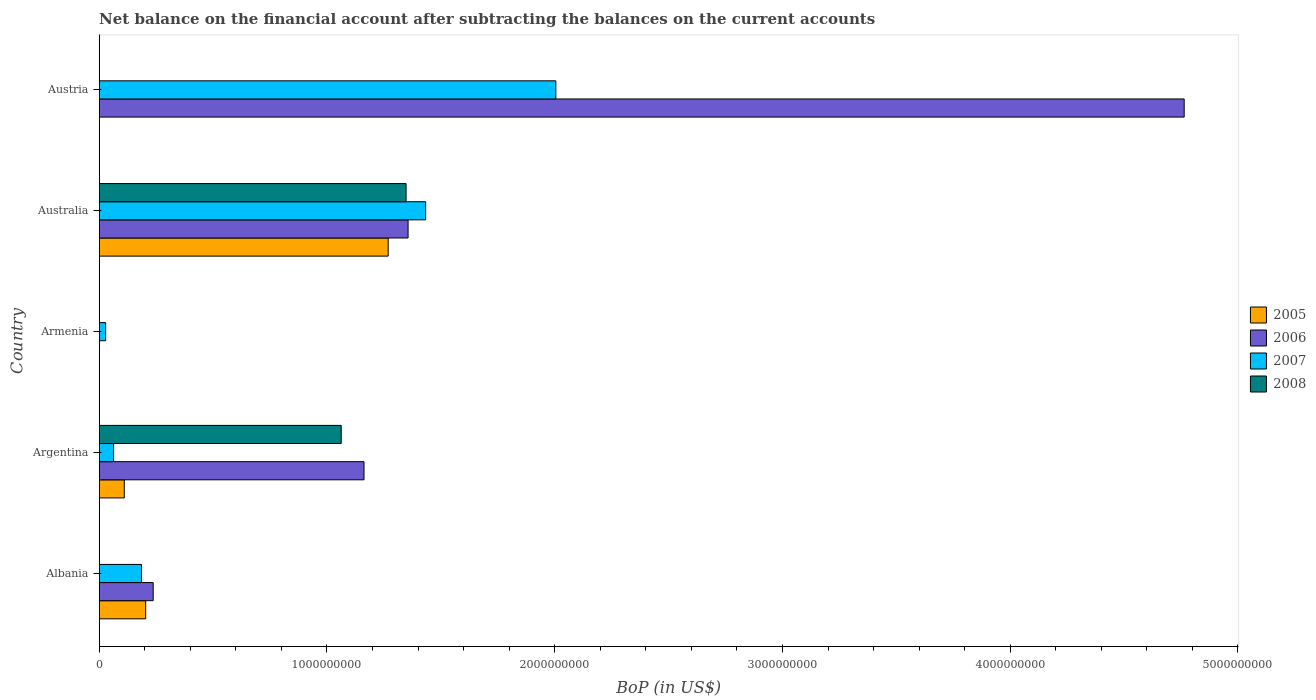Are the number of bars per tick equal to the number of legend labels?
Your response must be concise. No. How many bars are there on the 1st tick from the top?
Your answer should be compact. 2. What is the label of the 5th group of bars from the top?
Your answer should be compact. Albania. What is the Balance of Payments in 2007 in Austria?
Provide a succinct answer. 2.00e+09. Across all countries, what is the maximum Balance of Payments in 2008?
Offer a terse response. 1.35e+09. Across all countries, what is the minimum Balance of Payments in 2005?
Your answer should be very brief. 0. In which country was the Balance of Payments in 2005 maximum?
Your response must be concise. Australia. What is the total Balance of Payments in 2008 in the graph?
Provide a succinct answer. 2.41e+09. What is the difference between the Balance of Payments in 2007 in Albania and that in Argentina?
Ensure brevity in your answer.  1.22e+08. What is the difference between the Balance of Payments in 2006 in Austria and the Balance of Payments in 2008 in Armenia?
Your answer should be compact. 4.76e+09. What is the average Balance of Payments in 2008 per country?
Provide a short and direct response. 4.82e+08. What is the difference between the Balance of Payments in 2005 and Balance of Payments in 2007 in Australia?
Make the answer very short. -1.65e+08. In how many countries, is the Balance of Payments in 2005 greater than 2400000000 US$?
Your response must be concise. 0. What is the ratio of the Balance of Payments in 2006 in Australia to that in Austria?
Offer a terse response. 0.28. What is the difference between the highest and the second highest Balance of Payments in 2005?
Your answer should be compact. 1.06e+09. What is the difference between the highest and the lowest Balance of Payments in 2007?
Your response must be concise. 1.98e+09. Are all the bars in the graph horizontal?
Give a very brief answer. Yes. How many countries are there in the graph?
Keep it short and to the point. 5. Does the graph contain any zero values?
Offer a very short reply. Yes. Does the graph contain grids?
Ensure brevity in your answer.  No. Where does the legend appear in the graph?
Make the answer very short. Center right. How many legend labels are there?
Offer a very short reply. 4. What is the title of the graph?
Ensure brevity in your answer.  Net balance on the financial account after subtracting the balances on the current accounts. What is the label or title of the X-axis?
Your response must be concise. BoP (in US$). What is the BoP (in US$) of 2005 in Albania?
Ensure brevity in your answer.  2.04e+08. What is the BoP (in US$) of 2006 in Albania?
Keep it short and to the point. 2.37e+08. What is the BoP (in US$) in 2007 in Albania?
Offer a very short reply. 1.86e+08. What is the BoP (in US$) of 2005 in Argentina?
Make the answer very short. 1.10e+08. What is the BoP (in US$) of 2006 in Argentina?
Offer a very short reply. 1.16e+09. What is the BoP (in US$) of 2007 in Argentina?
Provide a succinct answer. 6.32e+07. What is the BoP (in US$) in 2008 in Argentina?
Your answer should be compact. 1.06e+09. What is the BoP (in US$) in 2005 in Armenia?
Provide a succinct answer. 0. What is the BoP (in US$) in 2007 in Armenia?
Your answer should be very brief. 2.83e+07. What is the BoP (in US$) in 2005 in Australia?
Give a very brief answer. 1.27e+09. What is the BoP (in US$) in 2006 in Australia?
Make the answer very short. 1.36e+09. What is the BoP (in US$) in 2007 in Australia?
Provide a succinct answer. 1.43e+09. What is the BoP (in US$) in 2008 in Australia?
Offer a very short reply. 1.35e+09. What is the BoP (in US$) in 2005 in Austria?
Offer a terse response. 0. What is the BoP (in US$) in 2006 in Austria?
Your response must be concise. 4.76e+09. What is the BoP (in US$) of 2007 in Austria?
Keep it short and to the point. 2.00e+09. What is the BoP (in US$) in 2008 in Austria?
Your response must be concise. 0. Across all countries, what is the maximum BoP (in US$) of 2005?
Your answer should be compact. 1.27e+09. Across all countries, what is the maximum BoP (in US$) of 2006?
Offer a very short reply. 4.76e+09. Across all countries, what is the maximum BoP (in US$) in 2007?
Ensure brevity in your answer.  2.00e+09. Across all countries, what is the maximum BoP (in US$) in 2008?
Provide a succinct answer. 1.35e+09. Across all countries, what is the minimum BoP (in US$) in 2005?
Provide a short and direct response. 0. Across all countries, what is the minimum BoP (in US$) of 2006?
Ensure brevity in your answer.  0. Across all countries, what is the minimum BoP (in US$) of 2007?
Your response must be concise. 2.83e+07. What is the total BoP (in US$) of 2005 in the graph?
Your response must be concise. 1.58e+09. What is the total BoP (in US$) in 2006 in the graph?
Offer a very short reply. 7.52e+09. What is the total BoP (in US$) of 2007 in the graph?
Your response must be concise. 3.72e+09. What is the total BoP (in US$) in 2008 in the graph?
Give a very brief answer. 2.41e+09. What is the difference between the BoP (in US$) in 2005 in Albania and that in Argentina?
Your response must be concise. 9.40e+07. What is the difference between the BoP (in US$) in 2006 in Albania and that in Argentina?
Ensure brevity in your answer.  -9.26e+08. What is the difference between the BoP (in US$) of 2007 in Albania and that in Argentina?
Make the answer very short. 1.22e+08. What is the difference between the BoP (in US$) of 2007 in Albania and that in Armenia?
Give a very brief answer. 1.57e+08. What is the difference between the BoP (in US$) of 2005 in Albania and that in Australia?
Keep it short and to the point. -1.06e+09. What is the difference between the BoP (in US$) of 2006 in Albania and that in Australia?
Your response must be concise. -1.12e+09. What is the difference between the BoP (in US$) in 2007 in Albania and that in Australia?
Make the answer very short. -1.25e+09. What is the difference between the BoP (in US$) in 2006 in Albania and that in Austria?
Keep it short and to the point. -4.53e+09. What is the difference between the BoP (in US$) in 2007 in Albania and that in Austria?
Your answer should be compact. -1.82e+09. What is the difference between the BoP (in US$) in 2007 in Argentina and that in Armenia?
Your response must be concise. 3.49e+07. What is the difference between the BoP (in US$) of 2005 in Argentina and that in Australia?
Provide a succinct answer. -1.16e+09. What is the difference between the BoP (in US$) of 2006 in Argentina and that in Australia?
Offer a terse response. -1.94e+08. What is the difference between the BoP (in US$) in 2007 in Argentina and that in Australia?
Give a very brief answer. -1.37e+09. What is the difference between the BoP (in US$) in 2008 in Argentina and that in Australia?
Provide a short and direct response. -2.85e+08. What is the difference between the BoP (in US$) in 2006 in Argentina and that in Austria?
Your response must be concise. -3.60e+09. What is the difference between the BoP (in US$) of 2007 in Argentina and that in Austria?
Your answer should be very brief. -1.94e+09. What is the difference between the BoP (in US$) of 2007 in Armenia and that in Australia?
Your answer should be very brief. -1.41e+09. What is the difference between the BoP (in US$) of 2007 in Armenia and that in Austria?
Your response must be concise. -1.98e+09. What is the difference between the BoP (in US$) of 2006 in Australia and that in Austria?
Your answer should be compact. -3.41e+09. What is the difference between the BoP (in US$) in 2007 in Australia and that in Austria?
Offer a terse response. -5.72e+08. What is the difference between the BoP (in US$) of 2005 in Albania and the BoP (in US$) of 2006 in Argentina?
Give a very brief answer. -9.59e+08. What is the difference between the BoP (in US$) of 2005 in Albania and the BoP (in US$) of 2007 in Argentina?
Your answer should be compact. 1.41e+08. What is the difference between the BoP (in US$) in 2005 in Albania and the BoP (in US$) in 2008 in Argentina?
Offer a very short reply. -8.59e+08. What is the difference between the BoP (in US$) in 2006 in Albania and the BoP (in US$) in 2007 in Argentina?
Offer a very short reply. 1.74e+08. What is the difference between the BoP (in US$) in 2006 in Albania and the BoP (in US$) in 2008 in Argentina?
Give a very brief answer. -8.26e+08. What is the difference between the BoP (in US$) in 2007 in Albania and the BoP (in US$) in 2008 in Argentina?
Provide a short and direct response. -8.77e+08. What is the difference between the BoP (in US$) of 2005 in Albania and the BoP (in US$) of 2007 in Armenia?
Provide a succinct answer. 1.76e+08. What is the difference between the BoP (in US$) in 2006 in Albania and the BoP (in US$) in 2007 in Armenia?
Offer a very short reply. 2.09e+08. What is the difference between the BoP (in US$) in 2005 in Albania and the BoP (in US$) in 2006 in Australia?
Provide a short and direct response. -1.15e+09. What is the difference between the BoP (in US$) in 2005 in Albania and the BoP (in US$) in 2007 in Australia?
Offer a terse response. -1.23e+09. What is the difference between the BoP (in US$) of 2005 in Albania and the BoP (in US$) of 2008 in Australia?
Provide a succinct answer. -1.14e+09. What is the difference between the BoP (in US$) of 2006 in Albania and the BoP (in US$) of 2007 in Australia?
Offer a terse response. -1.20e+09. What is the difference between the BoP (in US$) in 2006 in Albania and the BoP (in US$) in 2008 in Australia?
Your answer should be very brief. -1.11e+09. What is the difference between the BoP (in US$) in 2007 in Albania and the BoP (in US$) in 2008 in Australia?
Provide a succinct answer. -1.16e+09. What is the difference between the BoP (in US$) in 2005 in Albania and the BoP (in US$) in 2006 in Austria?
Give a very brief answer. -4.56e+09. What is the difference between the BoP (in US$) in 2005 in Albania and the BoP (in US$) in 2007 in Austria?
Your answer should be very brief. -1.80e+09. What is the difference between the BoP (in US$) of 2006 in Albania and the BoP (in US$) of 2007 in Austria?
Provide a succinct answer. -1.77e+09. What is the difference between the BoP (in US$) in 2005 in Argentina and the BoP (in US$) in 2007 in Armenia?
Provide a succinct answer. 8.18e+07. What is the difference between the BoP (in US$) in 2006 in Argentina and the BoP (in US$) in 2007 in Armenia?
Offer a terse response. 1.13e+09. What is the difference between the BoP (in US$) in 2005 in Argentina and the BoP (in US$) in 2006 in Australia?
Your answer should be very brief. -1.25e+09. What is the difference between the BoP (in US$) of 2005 in Argentina and the BoP (in US$) of 2007 in Australia?
Provide a short and direct response. -1.32e+09. What is the difference between the BoP (in US$) in 2005 in Argentina and the BoP (in US$) in 2008 in Australia?
Provide a succinct answer. -1.24e+09. What is the difference between the BoP (in US$) of 2006 in Argentina and the BoP (in US$) of 2007 in Australia?
Offer a very short reply. -2.71e+08. What is the difference between the BoP (in US$) of 2006 in Argentina and the BoP (in US$) of 2008 in Australia?
Make the answer very short. -1.85e+08. What is the difference between the BoP (in US$) of 2007 in Argentina and the BoP (in US$) of 2008 in Australia?
Give a very brief answer. -1.28e+09. What is the difference between the BoP (in US$) of 2005 in Argentina and the BoP (in US$) of 2006 in Austria?
Make the answer very short. -4.65e+09. What is the difference between the BoP (in US$) of 2005 in Argentina and the BoP (in US$) of 2007 in Austria?
Provide a short and direct response. -1.89e+09. What is the difference between the BoP (in US$) in 2006 in Argentina and the BoP (in US$) in 2007 in Austria?
Keep it short and to the point. -8.42e+08. What is the difference between the BoP (in US$) of 2007 in Armenia and the BoP (in US$) of 2008 in Australia?
Give a very brief answer. -1.32e+09. What is the difference between the BoP (in US$) in 2005 in Australia and the BoP (in US$) in 2006 in Austria?
Ensure brevity in your answer.  -3.50e+09. What is the difference between the BoP (in US$) of 2005 in Australia and the BoP (in US$) of 2007 in Austria?
Your answer should be compact. -7.36e+08. What is the difference between the BoP (in US$) of 2006 in Australia and the BoP (in US$) of 2007 in Austria?
Make the answer very short. -6.49e+08. What is the average BoP (in US$) of 2005 per country?
Your answer should be compact. 3.17e+08. What is the average BoP (in US$) in 2006 per country?
Keep it short and to the point. 1.50e+09. What is the average BoP (in US$) in 2007 per country?
Provide a short and direct response. 7.43e+08. What is the average BoP (in US$) in 2008 per country?
Your response must be concise. 4.82e+08. What is the difference between the BoP (in US$) of 2005 and BoP (in US$) of 2006 in Albania?
Your answer should be very brief. -3.29e+07. What is the difference between the BoP (in US$) in 2005 and BoP (in US$) in 2007 in Albania?
Your answer should be very brief. 1.85e+07. What is the difference between the BoP (in US$) in 2006 and BoP (in US$) in 2007 in Albania?
Keep it short and to the point. 5.14e+07. What is the difference between the BoP (in US$) in 2005 and BoP (in US$) in 2006 in Argentina?
Your response must be concise. -1.05e+09. What is the difference between the BoP (in US$) of 2005 and BoP (in US$) of 2007 in Argentina?
Offer a terse response. 4.69e+07. What is the difference between the BoP (in US$) in 2005 and BoP (in US$) in 2008 in Argentina?
Your answer should be very brief. -9.53e+08. What is the difference between the BoP (in US$) in 2006 and BoP (in US$) in 2007 in Argentina?
Your answer should be compact. 1.10e+09. What is the difference between the BoP (in US$) in 2006 and BoP (in US$) in 2008 in Argentina?
Give a very brief answer. 1.00e+08. What is the difference between the BoP (in US$) in 2007 and BoP (in US$) in 2008 in Argentina?
Provide a succinct answer. -9.99e+08. What is the difference between the BoP (in US$) in 2005 and BoP (in US$) in 2006 in Australia?
Provide a short and direct response. -8.74e+07. What is the difference between the BoP (in US$) in 2005 and BoP (in US$) in 2007 in Australia?
Give a very brief answer. -1.65e+08. What is the difference between the BoP (in US$) in 2005 and BoP (in US$) in 2008 in Australia?
Your response must be concise. -7.86e+07. What is the difference between the BoP (in US$) in 2006 and BoP (in US$) in 2007 in Australia?
Make the answer very short. -7.72e+07. What is the difference between the BoP (in US$) of 2006 and BoP (in US$) of 2008 in Australia?
Your answer should be compact. 8.75e+06. What is the difference between the BoP (in US$) in 2007 and BoP (in US$) in 2008 in Australia?
Make the answer very short. 8.59e+07. What is the difference between the BoP (in US$) in 2006 and BoP (in US$) in 2007 in Austria?
Make the answer very short. 2.76e+09. What is the ratio of the BoP (in US$) of 2005 in Albania to that in Argentina?
Keep it short and to the point. 1.85. What is the ratio of the BoP (in US$) of 2006 in Albania to that in Argentina?
Offer a terse response. 0.2. What is the ratio of the BoP (in US$) of 2007 in Albania to that in Argentina?
Provide a succinct answer. 2.94. What is the ratio of the BoP (in US$) in 2007 in Albania to that in Armenia?
Keep it short and to the point. 6.56. What is the ratio of the BoP (in US$) in 2005 in Albania to that in Australia?
Offer a terse response. 0.16. What is the ratio of the BoP (in US$) of 2006 in Albania to that in Australia?
Make the answer very short. 0.17. What is the ratio of the BoP (in US$) in 2007 in Albania to that in Australia?
Ensure brevity in your answer.  0.13. What is the ratio of the BoP (in US$) in 2006 in Albania to that in Austria?
Your answer should be compact. 0.05. What is the ratio of the BoP (in US$) of 2007 in Albania to that in Austria?
Ensure brevity in your answer.  0.09. What is the ratio of the BoP (in US$) of 2007 in Argentina to that in Armenia?
Offer a very short reply. 2.23. What is the ratio of the BoP (in US$) of 2005 in Argentina to that in Australia?
Your response must be concise. 0.09. What is the ratio of the BoP (in US$) in 2006 in Argentina to that in Australia?
Offer a terse response. 0.86. What is the ratio of the BoP (in US$) of 2007 in Argentina to that in Australia?
Make the answer very short. 0.04. What is the ratio of the BoP (in US$) of 2008 in Argentina to that in Australia?
Your response must be concise. 0.79. What is the ratio of the BoP (in US$) in 2006 in Argentina to that in Austria?
Your answer should be compact. 0.24. What is the ratio of the BoP (in US$) in 2007 in Argentina to that in Austria?
Ensure brevity in your answer.  0.03. What is the ratio of the BoP (in US$) in 2007 in Armenia to that in Australia?
Give a very brief answer. 0.02. What is the ratio of the BoP (in US$) of 2007 in Armenia to that in Austria?
Make the answer very short. 0.01. What is the ratio of the BoP (in US$) of 2006 in Australia to that in Austria?
Your answer should be very brief. 0.28. What is the ratio of the BoP (in US$) in 2007 in Australia to that in Austria?
Offer a very short reply. 0.71. What is the difference between the highest and the second highest BoP (in US$) of 2005?
Make the answer very short. 1.06e+09. What is the difference between the highest and the second highest BoP (in US$) of 2006?
Your response must be concise. 3.41e+09. What is the difference between the highest and the second highest BoP (in US$) in 2007?
Your answer should be very brief. 5.72e+08. What is the difference between the highest and the lowest BoP (in US$) of 2005?
Make the answer very short. 1.27e+09. What is the difference between the highest and the lowest BoP (in US$) in 2006?
Offer a terse response. 4.76e+09. What is the difference between the highest and the lowest BoP (in US$) of 2007?
Make the answer very short. 1.98e+09. What is the difference between the highest and the lowest BoP (in US$) in 2008?
Make the answer very short. 1.35e+09. 